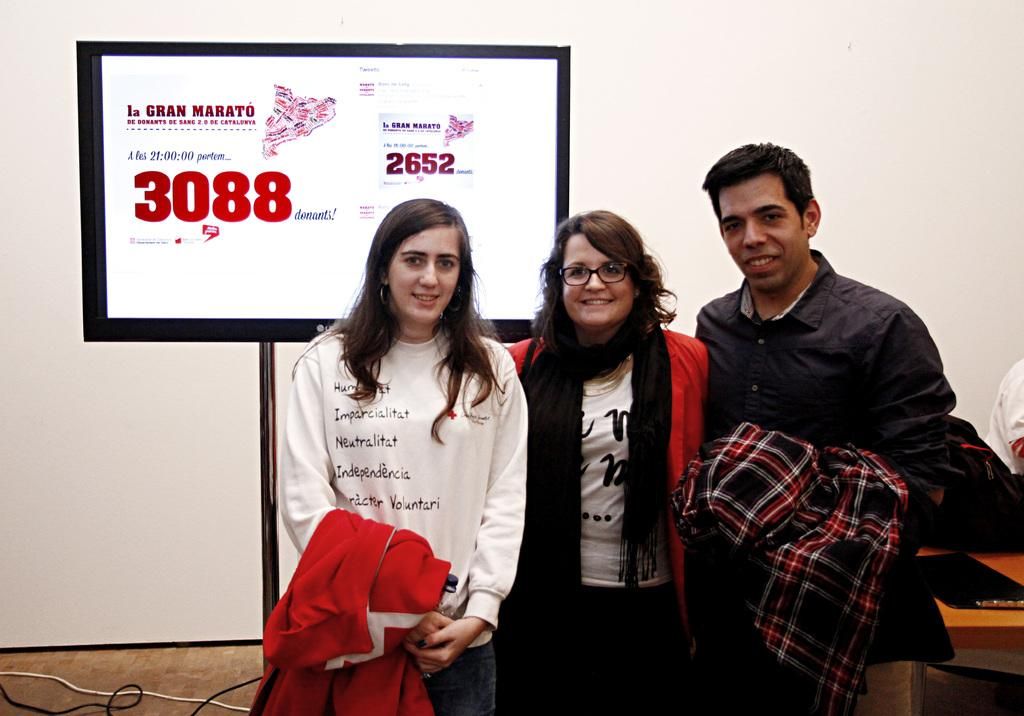What is the color of the wall in the image? The wall in the image is white. What can be seen on the wall in the image? There is a screen on the wall in the image. Who or what is in the front of the image? There are people standing in the front of the image. What is present on the table in the image? There is a laptop on the table in the image. What might the people be using the laptop for in the image? The people might be using the laptop for work, communication, or entertainment. What type of drink is being served on the table in the image? There is no drink present on the table in the image; only a laptop is visible. What advice is being given by the people in the image? There is no indication of any advice being given in the image; the people are simply standing in front of the wall with the screen. 